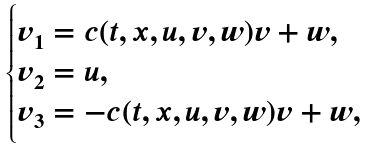<formula> <loc_0><loc_0><loc_500><loc_500>\begin{cases} v _ { 1 } = c ( t , x , u , v , w ) v + w , \\ v _ { 2 } = u , \\ v _ { 3 } = - c ( t , x , u , v , w ) v + w , \end{cases}</formula> 